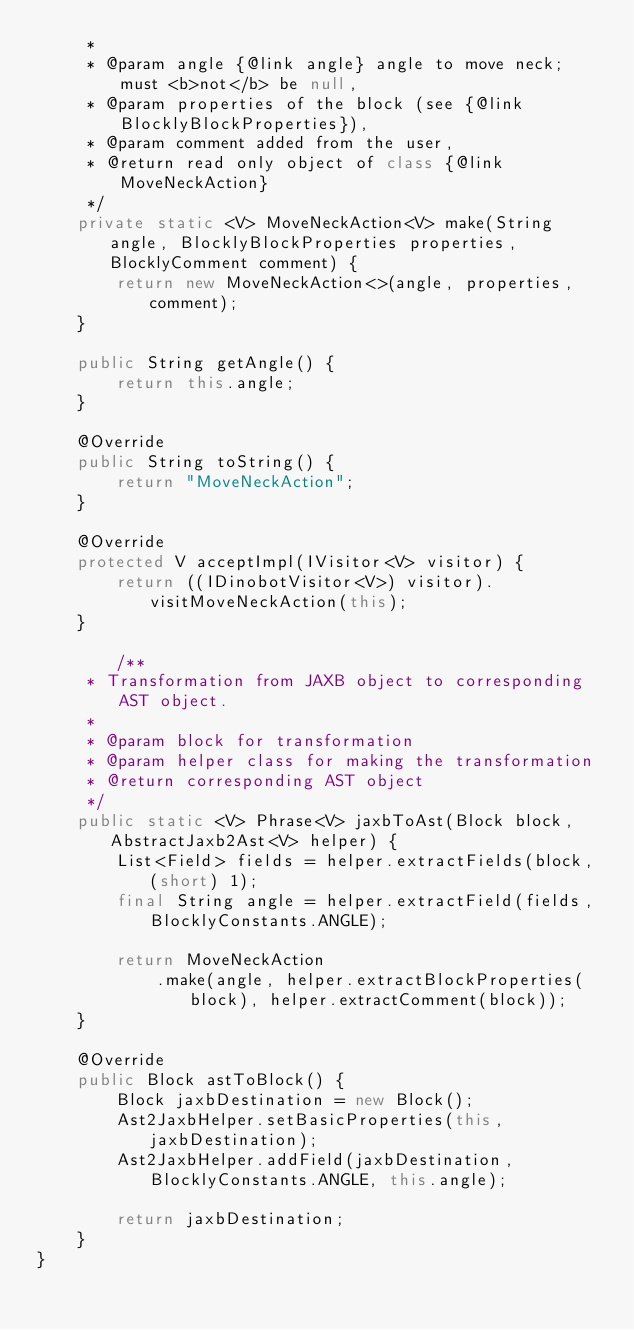<code> <loc_0><loc_0><loc_500><loc_500><_Java_>     *
     * @param angle {@link angle} angle to move neck; must <b>not</b> be null,
     * @param properties of the block (see {@link BlocklyBlockProperties}),
     * @param comment added from the user,
     * @return read only object of class {@link MoveNeckAction}
     */
    private static <V> MoveNeckAction<V> make(String angle, BlocklyBlockProperties properties, BlocklyComment comment) {
        return new MoveNeckAction<>(angle, properties, comment);
    }

    public String getAngle() {
        return this.angle;
    }

    @Override
    public String toString() {
        return "MoveNeckAction";
    }

    @Override
    protected V acceptImpl(IVisitor<V> visitor) {
        return ((IDinobotVisitor<V>) visitor).visitMoveNeckAction(this);
    }

        /**
     * Transformation from JAXB object to corresponding AST object.
     *
     * @param block for transformation
     * @param helper class for making the transformation
     * @return corresponding AST object
     */
    public static <V> Phrase<V> jaxbToAst(Block block, AbstractJaxb2Ast<V> helper) {
        List<Field> fields = helper.extractFields(block, (short) 1);
        final String angle = helper.extractField(fields, BlocklyConstants.ANGLE);

        return MoveNeckAction
            .make(angle, helper.extractBlockProperties(block), helper.extractComment(block));
    }

    @Override
    public Block astToBlock() {
        Block jaxbDestination = new Block();
        Ast2JaxbHelper.setBasicProperties(this, jaxbDestination);
        Ast2JaxbHelper.addField(jaxbDestination, BlocklyConstants.ANGLE, this.angle);

        return jaxbDestination;
    }
}
</code> 